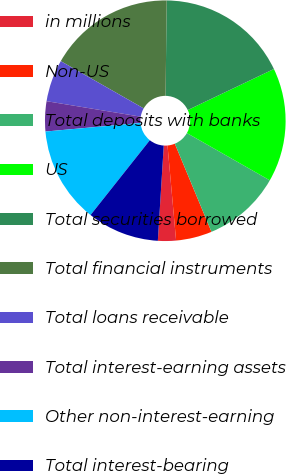Convert chart. <chart><loc_0><loc_0><loc_500><loc_500><pie_chart><fcel>in millions<fcel>Non-US<fcel>Total deposits with banks<fcel>US<fcel>Total securities borrowed<fcel>Total financial instruments<fcel>Total loans receivable<fcel>Total interest-earning assets<fcel>Other non-interest-earning<fcel>Total interest-bearing<nl><fcel>2.42%<fcel>4.84%<fcel>10.48%<fcel>15.32%<fcel>17.74%<fcel>16.94%<fcel>5.65%<fcel>4.03%<fcel>12.9%<fcel>9.68%<nl></chart> 